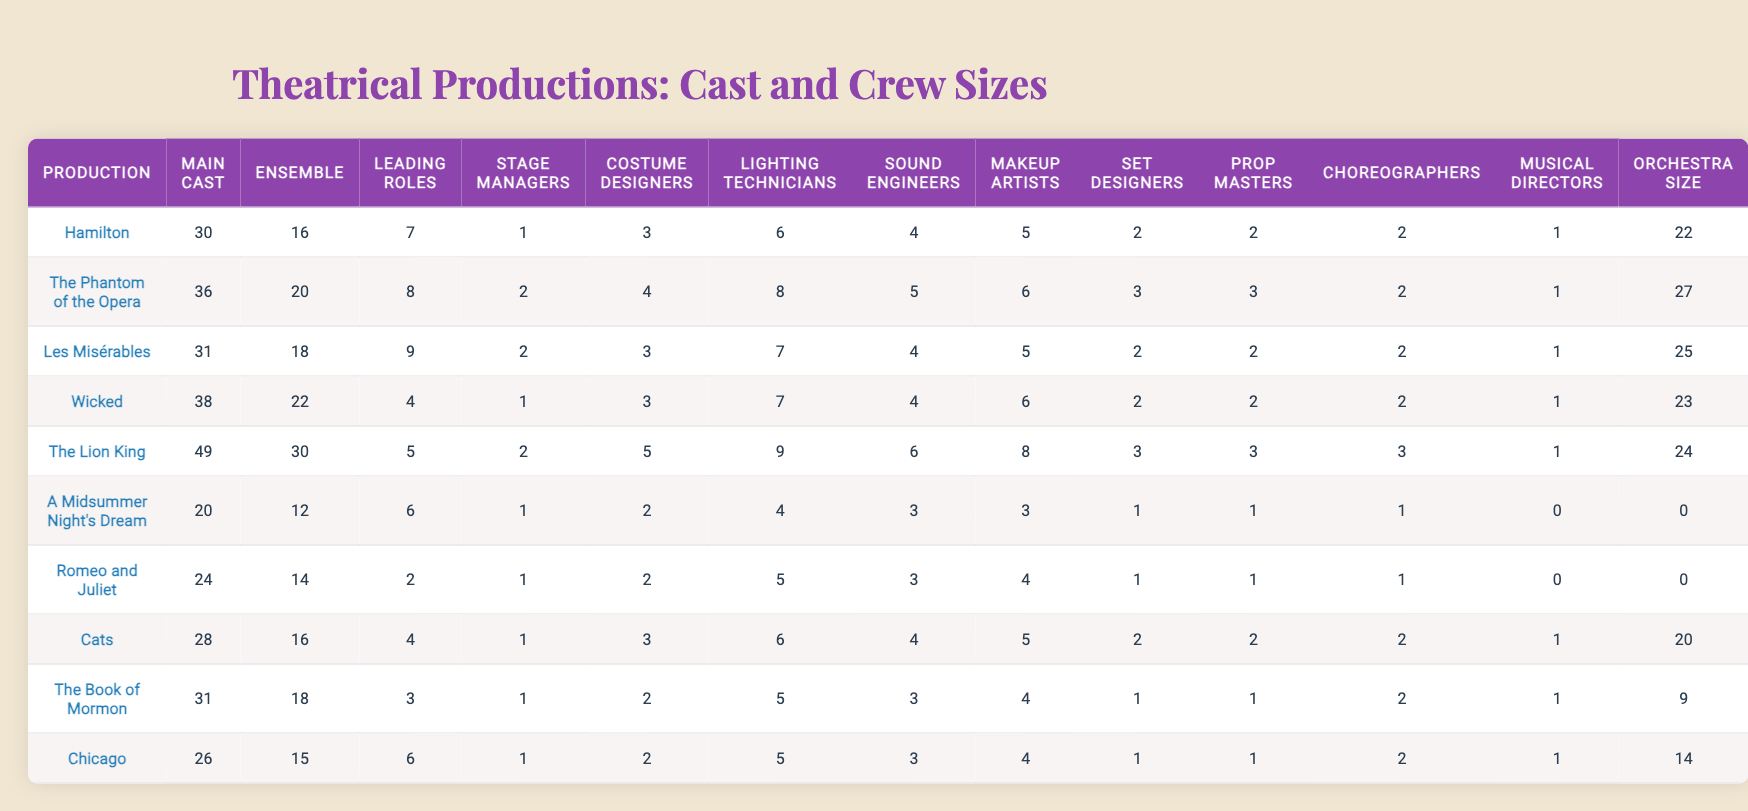What is the largest Main Cast size among the productions? The Main Cast sizes for each production are listed, with "The Lion King" having the highest number at 49.
Answer: 49 Which production has the fewest Ensemble members? The Ensemble sizes are compared, and "A Midsummer Night's Dream" has the lowest number at 12.
Answer: 12 How many Leading Roles are there in "Wicked"? The table shows that "Wicked" has 4 Leading Roles.
Answer: 4 Does "The Phantom of the Opera" have more Stage Managers than "Chicago"? "The Phantom of the Opera" has 2 Stage Managers, while "Chicago" has 1. Therefore, it is true that "The Phantom of the Opera" has more Stage Managers.
Answer: Yes Which production has the highest number of Costume Designers? By examining the table, "The Lion King" has 5 Costume Designers, the highest number.
Answer: 5 What is the average number of Lighting Technicians across all productions? Summing the Lighting Technicians count: (6 + 8 + 7 + 7 + 9 + 4 + 5 + 6 + 5 + 5) = 57, and dividing by the count of productions (10), gives an average of 5.7.
Answer: 5.7 How many more Sound Engineers does "Hamilton" have compared to "A Midsummer Night's Dream"? "Hamilton" has 4 Sound Engineers, while "A Midsummer Night's Dream" has 3. The difference is 4 - 3 = 1.
Answer: 1 Is the number of Makeup Artists in "Cats" less than in "The Lion King"? "Cats" has 5 Makeup Artists, while "The Lion King" has 8, making the statement true as 5 is less than 8.
Answer: Yes Which production has a higher orchestra size: "Chicago" or "Cats"? "Chicago" has an orchestra of size 14, while "Cats" has 20. Thus, "Cats" has the higher orchestra size.
Answer: Cats What is the total number of Stage Managers in all productions? Summing the Stage Manager counts: (1 + 2 + 2 + 1 + 2 + 1 + 1 + 1 + 1 + 1) = 14.
Answer: 14 How many productions have an Orchestra Size of 0? According to the table, "A Midsummer Night's Dream" and "Romeo and Juliet" both have an Orchestra Size of 0. Thus, there are 2 productions.
Answer: 2 What is the difference in Main Cast size between "Les Misérables" and "Cats"? "Les Misérables" has 31 in the Main Cast, and "Cats" has 28. The difference is 31 - 28 = 3.
Answer: 3 